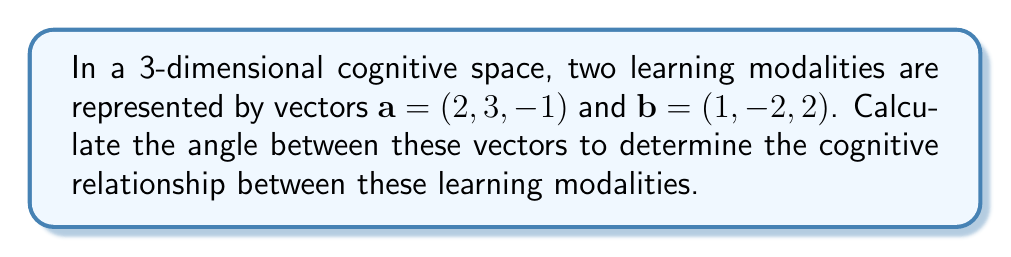Solve this math problem. To find the angle between two vectors in a 3-dimensional space, we can use the dot product formula:

$$\cos \theta = \frac{\mathbf{a} \cdot \mathbf{b}}{|\mathbf{a}||\mathbf{b}|}$$

Where $\mathbf{a} \cdot \mathbf{b}$ is the dot product of the vectors, and $|\mathbf{a}|$ and $|\mathbf{b}|$ are the magnitudes of vectors $\mathbf{a}$ and $\mathbf{b}$ respectively.

Step 1: Calculate the dot product $\mathbf{a} \cdot \mathbf{b}$
$$\mathbf{a} \cdot \mathbf{b} = (2)(1) + (3)(-2) + (-1)(2) = 2 - 6 - 2 = -6$$

Step 2: Calculate the magnitudes of $\mathbf{a}$ and $\mathbf{b}$
$$|\mathbf{a}| = \sqrt{2^2 + 3^2 + (-1)^2} = \sqrt{4 + 9 + 1} = \sqrt{14}$$
$$|\mathbf{b}| = \sqrt{1^2 + (-2)^2 + 2^2} = \sqrt{1 + 4 + 4} = 3$$

Step 3: Apply the dot product formula
$$\cos \theta = \frac{-6}{\sqrt{14} \cdot 3} = \frac{-6}{3\sqrt{14}} = -\frac{2}{\sqrt{14}}$$

Step 4: Take the inverse cosine (arccos) of both sides
$$\theta = \arccos\left(-\frac{2}{\sqrt{14}}\right)$$

Step 5: Calculate the result (in radians)
$$\theta \approx 2.3562$$

Step 6: Convert to degrees
$$\theta \approx 2.3562 \cdot \frac{180}{\pi} \approx 135.0°$$
Answer: $135.0°$ 